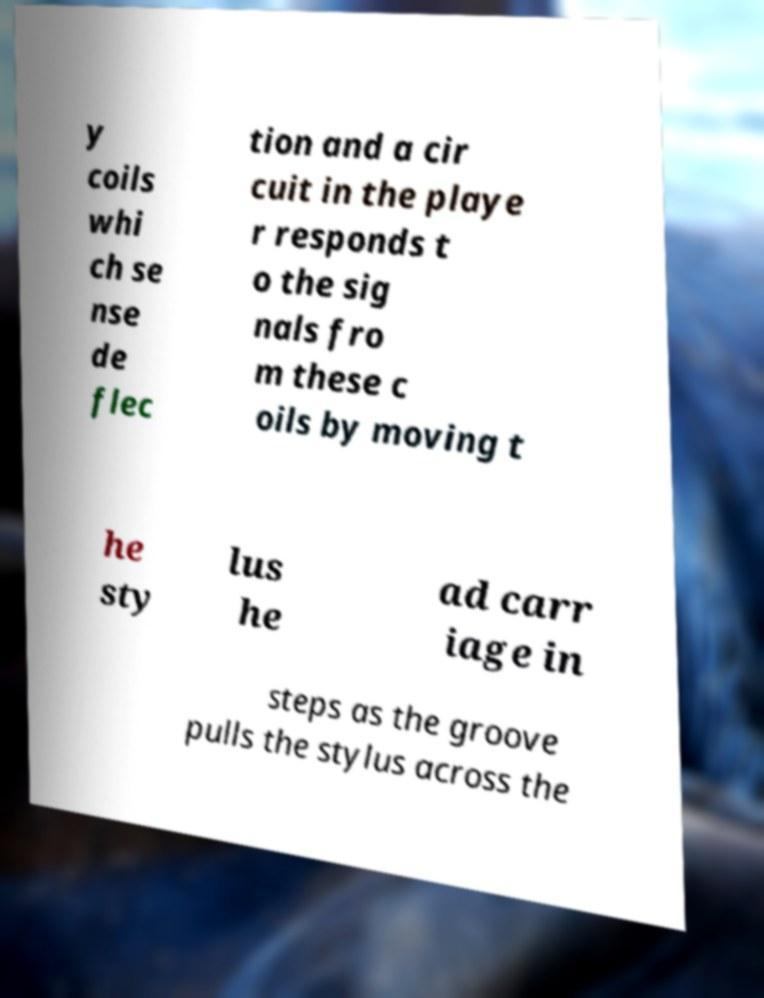Could you assist in decoding the text presented in this image and type it out clearly? y coils whi ch se nse de flec tion and a cir cuit in the playe r responds t o the sig nals fro m these c oils by moving t he sty lus he ad carr iage in steps as the groove pulls the stylus across the 